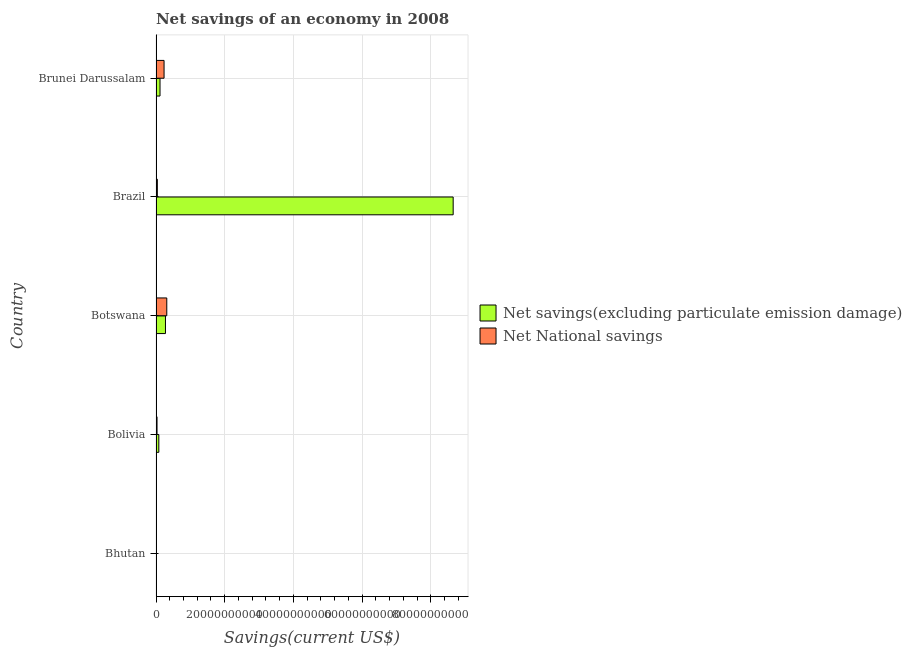How many different coloured bars are there?
Provide a short and direct response. 2. How many groups of bars are there?
Provide a short and direct response. 5. Are the number of bars per tick equal to the number of legend labels?
Offer a terse response. Yes. Are the number of bars on each tick of the Y-axis equal?
Your answer should be compact. Yes. How many bars are there on the 3rd tick from the top?
Ensure brevity in your answer.  2. What is the label of the 3rd group of bars from the top?
Keep it short and to the point. Botswana. What is the net savings(excluding particulate emission damage) in Brunei Darussalam?
Your answer should be very brief. 1.16e+09. Across all countries, what is the maximum net savings(excluding particulate emission damage)?
Your response must be concise. 8.65e+1. Across all countries, what is the minimum net savings(excluding particulate emission damage)?
Your response must be concise. 1.29e+08. In which country was the net national savings maximum?
Your answer should be very brief. Botswana. In which country was the net savings(excluding particulate emission damage) minimum?
Provide a succinct answer. Bhutan. What is the total net national savings in the graph?
Offer a very short reply. 6.20e+09. What is the difference between the net national savings in Bolivia and that in Brunei Darussalam?
Give a very brief answer. -2.05e+09. What is the difference between the net national savings in Bolivia and the net savings(excluding particulate emission damage) in Brunei Darussalam?
Your answer should be very brief. -8.72e+08. What is the average net savings(excluding particulate emission damage) per country?
Ensure brevity in your answer.  1.83e+1. What is the difference between the net savings(excluding particulate emission damage) and net national savings in Bolivia?
Make the answer very short. 5.26e+08. What is the ratio of the net savings(excluding particulate emission damage) in Brazil to that in Brunei Darussalam?
Provide a succinct answer. 74.29. Is the difference between the net national savings in Bhutan and Brunei Darussalam greater than the difference between the net savings(excluding particulate emission damage) in Bhutan and Brunei Darussalam?
Your response must be concise. No. What is the difference between the highest and the second highest net savings(excluding particulate emission damage)?
Provide a short and direct response. 8.38e+1. What is the difference between the highest and the lowest net national savings?
Keep it short and to the point. 3.08e+09. What does the 2nd bar from the top in Brazil represents?
Your response must be concise. Net savings(excluding particulate emission damage). What does the 2nd bar from the bottom in Brunei Darussalam represents?
Your answer should be very brief. Net National savings. How many bars are there?
Offer a terse response. 10. Where does the legend appear in the graph?
Your response must be concise. Center right. How many legend labels are there?
Keep it short and to the point. 2. What is the title of the graph?
Provide a succinct answer. Net savings of an economy in 2008. What is the label or title of the X-axis?
Provide a short and direct response. Savings(current US$). What is the label or title of the Y-axis?
Your response must be concise. Country. What is the Savings(current US$) in Net savings(excluding particulate emission damage) in Bhutan?
Your answer should be very brief. 1.29e+08. What is the Savings(current US$) of Net National savings in Bhutan?
Provide a succinct answer. 4.90e+07. What is the Savings(current US$) in Net savings(excluding particulate emission damage) in Bolivia?
Offer a very short reply. 8.19e+08. What is the Savings(current US$) in Net National savings in Bolivia?
Give a very brief answer. 2.92e+08. What is the Savings(current US$) of Net savings(excluding particulate emission damage) in Botswana?
Ensure brevity in your answer.  2.75e+09. What is the Savings(current US$) of Net National savings in Botswana?
Keep it short and to the point. 3.13e+09. What is the Savings(current US$) in Net savings(excluding particulate emission damage) in Brazil?
Give a very brief answer. 8.65e+1. What is the Savings(current US$) in Net National savings in Brazil?
Provide a succinct answer. 3.86e+08. What is the Savings(current US$) of Net savings(excluding particulate emission damage) in Brunei Darussalam?
Keep it short and to the point. 1.16e+09. What is the Savings(current US$) in Net National savings in Brunei Darussalam?
Your answer should be compact. 2.34e+09. Across all countries, what is the maximum Savings(current US$) of Net savings(excluding particulate emission damage)?
Your response must be concise. 8.65e+1. Across all countries, what is the maximum Savings(current US$) of Net National savings?
Keep it short and to the point. 3.13e+09. Across all countries, what is the minimum Savings(current US$) of Net savings(excluding particulate emission damage)?
Make the answer very short. 1.29e+08. Across all countries, what is the minimum Savings(current US$) in Net National savings?
Your answer should be compact. 4.90e+07. What is the total Savings(current US$) of Net savings(excluding particulate emission damage) in the graph?
Give a very brief answer. 9.14e+1. What is the total Savings(current US$) in Net National savings in the graph?
Your answer should be compact. 6.20e+09. What is the difference between the Savings(current US$) of Net savings(excluding particulate emission damage) in Bhutan and that in Bolivia?
Keep it short and to the point. -6.89e+08. What is the difference between the Savings(current US$) of Net National savings in Bhutan and that in Bolivia?
Ensure brevity in your answer.  -2.43e+08. What is the difference between the Savings(current US$) of Net savings(excluding particulate emission damage) in Bhutan and that in Botswana?
Make the answer very short. -2.62e+09. What is the difference between the Savings(current US$) in Net National savings in Bhutan and that in Botswana?
Provide a short and direct response. -3.08e+09. What is the difference between the Savings(current US$) of Net savings(excluding particulate emission damage) in Bhutan and that in Brazil?
Offer a terse response. -8.64e+1. What is the difference between the Savings(current US$) in Net National savings in Bhutan and that in Brazil?
Your answer should be compact. -3.37e+08. What is the difference between the Savings(current US$) of Net savings(excluding particulate emission damage) in Bhutan and that in Brunei Darussalam?
Ensure brevity in your answer.  -1.03e+09. What is the difference between the Savings(current US$) of Net National savings in Bhutan and that in Brunei Darussalam?
Offer a terse response. -2.29e+09. What is the difference between the Savings(current US$) of Net savings(excluding particulate emission damage) in Bolivia and that in Botswana?
Your response must be concise. -1.93e+09. What is the difference between the Savings(current US$) of Net National savings in Bolivia and that in Botswana?
Your answer should be very brief. -2.84e+09. What is the difference between the Savings(current US$) in Net savings(excluding particulate emission damage) in Bolivia and that in Brazil?
Keep it short and to the point. -8.57e+1. What is the difference between the Savings(current US$) in Net National savings in Bolivia and that in Brazil?
Keep it short and to the point. -9.36e+07. What is the difference between the Savings(current US$) in Net savings(excluding particulate emission damage) in Bolivia and that in Brunei Darussalam?
Ensure brevity in your answer.  -3.46e+08. What is the difference between the Savings(current US$) of Net National savings in Bolivia and that in Brunei Darussalam?
Offer a very short reply. -2.05e+09. What is the difference between the Savings(current US$) in Net savings(excluding particulate emission damage) in Botswana and that in Brazil?
Provide a short and direct response. -8.38e+1. What is the difference between the Savings(current US$) in Net National savings in Botswana and that in Brazil?
Your answer should be very brief. 2.75e+09. What is the difference between the Savings(current US$) of Net savings(excluding particulate emission damage) in Botswana and that in Brunei Darussalam?
Your answer should be very brief. 1.58e+09. What is the difference between the Savings(current US$) in Net National savings in Botswana and that in Brunei Darussalam?
Provide a short and direct response. 7.93e+08. What is the difference between the Savings(current US$) of Net savings(excluding particulate emission damage) in Brazil and that in Brunei Darussalam?
Your response must be concise. 8.53e+1. What is the difference between the Savings(current US$) of Net National savings in Brazil and that in Brunei Darussalam?
Your answer should be compact. -1.95e+09. What is the difference between the Savings(current US$) in Net savings(excluding particulate emission damage) in Bhutan and the Savings(current US$) in Net National savings in Bolivia?
Your answer should be very brief. -1.63e+08. What is the difference between the Savings(current US$) in Net savings(excluding particulate emission damage) in Bhutan and the Savings(current US$) in Net National savings in Botswana?
Your response must be concise. -3.00e+09. What is the difference between the Savings(current US$) of Net savings(excluding particulate emission damage) in Bhutan and the Savings(current US$) of Net National savings in Brazil?
Your answer should be compact. -2.56e+08. What is the difference between the Savings(current US$) of Net savings(excluding particulate emission damage) in Bhutan and the Savings(current US$) of Net National savings in Brunei Darussalam?
Your answer should be very brief. -2.21e+09. What is the difference between the Savings(current US$) in Net savings(excluding particulate emission damage) in Bolivia and the Savings(current US$) in Net National savings in Botswana?
Your answer should be very brief. -2.31e+09. What is the difference between the Savings(current US$) in Net savings(excluding particulate emission damage) in Bolivia and the Savings(current US$) in Net National savings in Brazil?
Make the answer very short. 4.33e+08. What is the difference between the Savings(current US$) of Net savings(excluding particulate emission damage) in Bolivia and the Savings(current US$) of Net National savings in Brunei Darussalam?
Your answer should be compact. -1.52e+09. What is the difference between the Savings(current US$) of Net savings(excluding particulate emission damage) in Botswana and the Savings(current US$) of Net National savings in Brazil?
Provide a short and direct response. 2.36e+09. What is the difference between the Savings(current US$) of Net savings(excluding particulate emission damage) in Botswana and the Savings(current US$) of Net National savings in Brunei Darussalam?
Provide a short and direct response. 4.09e+08. What is the difference between the Savings(current US$) of Net savings(excluding particulate emission damage) in Brazil and the Savings(current US$) of Net National savings in Brunei Darussalam?
Your answer should be compact. 8.42e+1. What is the average Savings(current US$) of Net savings(excluding particulate emission damage) per country?
Keep it short and to the point. 1.83e+1. What is the average Savings(current US$) of Net National savings per country?
Your response must be concise. 1.24e+09. What is the difference between the Savings(current US$) of Net savings(excluding particulate emission damage) and Savings(current US$) of Net National savings in Bhutan?
Your response must be concise. 8.05e+07. What is the difference between the Savings(current US$) of Net savings(excluding particulate emission damage) and Savings(current US$) of Net National savings in Bolivia?
Your response must be concise. 5.26e+08. What is the difference between the Savings(current US$) in Net savings(excluding particulate emission damage) and Savings(current US$) in Net National savings in Botswana?
Provide a succinct answer. -3.84e+08. What is the difference between the Savings(current US$) in Net savings(excluding particulate emission damage) and Savings(current US$) in Net National savings in Brazil?
Your answer should be compact. 8.61e+1. What is the difference between the Savings(current US$) in Net savings(excluding particulate emission damage) and Savings(current US$) in Net National savings in Brunei Darussalam?
Your response must be concise. -1.17e+09. What is the ratio of the Savings(current US$) in Net savings(excluding particulate emission damage) in Bhutan to that in Bolivia?
Ensure brevity in your answer.  0.16. What is the ratio of the Savings(current US$) of Net National savings in Bhutan to that in Bolivia?
Provide a succinct answer. 0.17. What is the ratio of the Savings(current US$) of Net savings(excluding particulate emission damage) in Bhutan to that in Botswana?
Offer a terse response. 0.05. What is the ratio of the Savings(current US$) of Net National savings in Bhutan to that in Botswana?
Your response must be concise. 0.02. What is the ratio of the Savings(current US$) of Net savings(excluding particulate emission damage) in Bhutan to that in Brazil?
Provide a succinct answer. 0. What is the ratio of the Savings(current US$) of Net National savings in Bhutan to that in Brazil?
Provide a succinct answer. 0.13. What is the ratio of the Savings(current US$) in Net savings(excluding particulate emission damage) in Bhutan to that in Brunei Darussalam?
Make the answer very short. 0.11. What is the ratio of the Savings(current US$) in Net National savings in Bhutan to that in Brunei Darussalam?
Provide a succinct answer. 0.02. What is the ratio of the Savings(current US$) of Net savings(excluding particulate emission damage) in Bolivia to that in Botswana?
Provide a short and direct response. 0.3. What is the ratio of the Savings(current US$) in Net National savings in Bolivia to that in Botswana?
Your answer should be very brief. 0.09. What is the ratio of the Savings(current US$) of Net savings(excluding particulate emission damage) in Bolivia to that in Brazil?
Keep it short and to the point. 0.01. What is the ratio of the Savings(current US$) in Net National savings in Bolivia to that in Brazil?
Provide a short and direct response. 0.76. What is the ratio of the Savings(current US$) in Net savings(excluding particulate emission damage) in Bolivia to that in Brunei Darussalam?
Your response must be concise. 0.7. What is the ratio of the Savings(current US$) of Net National savings in Bolivia to that in Brunei Darussalam?
Ensure brevity in your answer.  0.12. What is the ratio of the Savings(current US$) in Net savings(excluding particulate emission damage) in Botswana to that in Brazil?
Keep it short and to the point. 0.03. What is the ratio of the Savings(current US$) of Net National savings in Botswana to that in Brazil?
Offer a very short reply. 8.12. What is the ratio of the Savings(current US$) of Net savings(excluding particulate emission damage) in Botswana to that in Brunei Darussalam?
Offer a very short reply. 2.36. What is the ratio of the Savings(current US$) in Net National savings in Botswana to that in Brunei Darussalam?
Your answer should be compact. 1.34. What is the ratio of the Savings(current US$) in Net savings(excluding particulate emission damage) in Brazil to that in Brunei Darussalam?
Your answer should be compact. 74.29. What is the ratio of the Savings(current US$) in Net National savings in Brazil to that in Brunei Darussalam?
Offer a terse response. 0.16. What is the difference between the highest and the second highest Savings(current US$) of Net savings(excluding particulate emission damage)?
Your answer should be compact. 8.38e+1. What is the difference between the highest and the second highest Savings(current US$) of Net National savings?
Your answer should be compact. 7.93e+08. What is the difference between the highest and the lowest Savings(current US$) in Net savings(excluding particulate emission damage)?
Keep it short and to the point. 8.64e+1. What is the difference between the highest and the lowest Savings(current US$) of Net National savings?
Ensure brevity in your answer.  3.08e+09. 